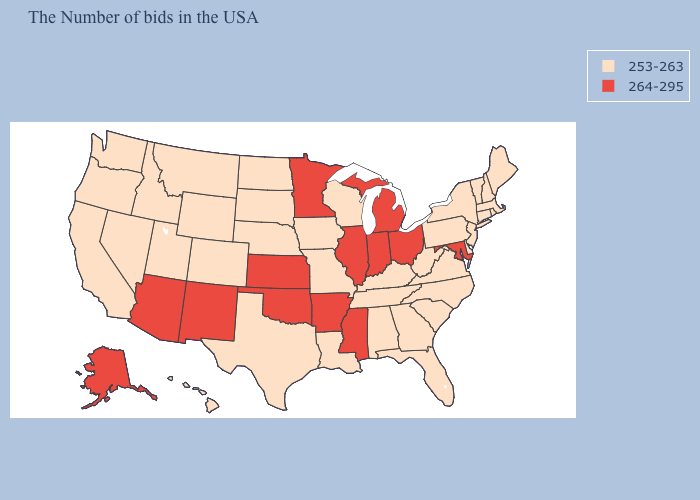What is the lowest value in states that border Missouri?
Quick response, please. 253-263. Among the states that border Oklahoma , which have the highest value?
Keep it brief. Arkansas, Kansas, New Mexico. What is the value of North Dakota?
Keep it brief. 253-263. Name the states that have a value in the range 253-263?
Quick response, please. Maine, Massachusetts, Rhode Island, New Hampshire, Vermont, Connecticut, New York, New Jersey, Delaware, Pennsylvania, Virginia, North Carolina, South Carolina, West Virginia, Florida, Georgia, Kentucky, Alabama, Tennessee, Wisconsin, Louisiana, Missouri, Iowa, Nebraska, Texas, South Dakota, North Dakota, Wyoming, Colorado, Utah, Montana, Idaho, Nevada, California, Washington, Oregon, Hawaii. Name the states that have a value in the range 264-295?
Quick response, please. Maryland, Ohio, Michigan, Indiana, Illinois, Mississippi, Arkansas, Minnesota, Kansas, Oklahoma, New Mexico, Arizona, Alaska. Does Indiana have the highest value in the USA?
Answer briefly. Yes. What is the lowest value in the USA?
Be succinct. 253-263. Does South Carolina have the lowest value in the USA?
Write a very short answer. Yes. What is the value of Ohio?
Give a very brief answer. 264-295. What is the highest value in the West ?
Quick response, please. 264-295. Does the map have missing data?
Keep it brief. No. Does the first symbol in the legend represent the smallest category?
Be succinct. Yes. Name the states that have a value in the range 253-263?
Write a very short answer. Maine, Massachusetts, Rhode Island, New Hampshire, Vermont, Connecticut, New York, New Jersey, Delaware, Pennsylvania, Virginia, North Carolina, South Carolina, West Virginia, Florida, Georgia, Kentucky, Alabama, Tennessee, Wisconsin, Louisiana, Missouri, Iowa, Nebraska, Texas, South Dakota, North Dakota, Wyoming, Colorado, Utah, Montana, Idaho, Nevada, California, Washington, Oregon, Hawaii. Among the states that border California , does Oregon have the lowest value?
Write a very short answer. Yes. Does the map have missing data?
Be succinct. No. 